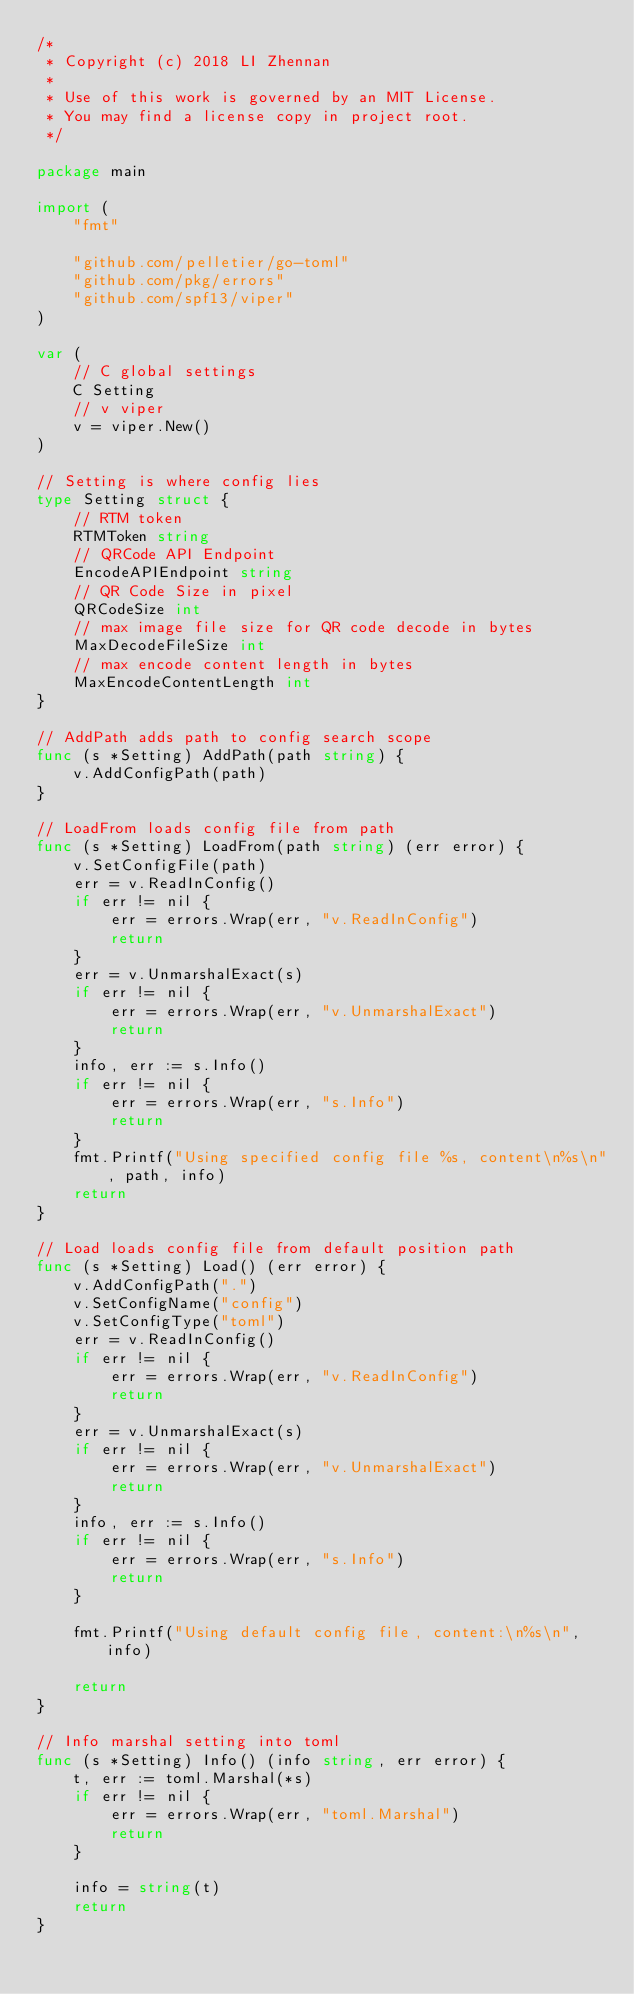Convert code to text. <code><loc_0><loc_0><loc_500><loc_500><_Go_>/*
 * Copyright (c) 2018 LI Zhennan
 *
 * Use of this work is governed by an MIT License.
 * You may find a license copy in project root.
 */

package main

import (
	"fmt"

	"github.com/pelletier/go-toml"
	"github.com/pkg/errors"
	"github.com/spf13/viper"
)

var (
	// C global settings
	C Setting
	// v viper
	v = viper.New()
)

// Setting is where config lies
type Setting struct {
	// RTM token
	RTMToken string
	// QRCode API Endpoint
	EncodeAPIEndpoint string
	// QR Code Size in pixel
	QRCodeSize int
	// max image file size for QR code decode in bytes
	MaxDecodeFileSize int
	// max encode content length in bytes
	MaxEncodeContentLength int
}

// AddPath adds path to config search scope
func (s *Setting) AddPath(path string) {
	v.AddConfigPath(path)
}

// LoadFrom loads config file from path
func (s *Setting) LoadFrom(path string) (err error) {
	v.SetConfigFile(path)
	err = v.ReadInConfig()
	if err != nil {
		err = errors.Wrap(err, "v.ReadInConfig")
		return
	}
	err = v.UnmarshalExact(s)
	if err != nil {
		err = errors.Wrap(err, "v.UnmarshalExact")
		return
	}
	info, err := s.Info()
	if err != nil {
		err = errors.Wrap(err, "s.Info")
		return
	}
	fmt.Printf("Using specified config file %s, content\n%s\n", path, info)
	return
}

// Load loads config file from default position path
func (s *Setting) Load() (err error) {
	v.AddConfigPath(".")
	v.SetConfigName("config")
	v.SetConfigType("toml")
	err = v.ReadInConfig()
	if err != nil {
		err = errors.Wrap(err, "v.ReadInConfig")
		return
	}
	err = v.UnmarshalExact(s)
	if err != nil {
		err = errors.Wrap(err, "v.UnmarshalExact")
		return
	}
	info, err := s.Info()
	if err != nil {
		err = errors.Wrap(err, "s.Info")
		return
	}

	fmt.Printf("Using default config file, content:\n%s\n", info)

	return
}

// Info marshal setting into toml
func (s *Setting) Info() (info string, err error) {
	t, err := toml.Marshal(*s)
	if err != nil {
		err = errors.Wrap(err, "toml.Marshal")
		return
	}

	info = string(t)
	return
}
</code> 